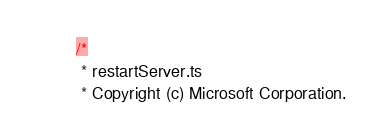Convert code to text. <code><loc_0><loc_0><loc_500><loc_500><_TypeScript_>/*
 * restartServer.ts
 * Copyright (c) Microsoft Corporation.</code> 